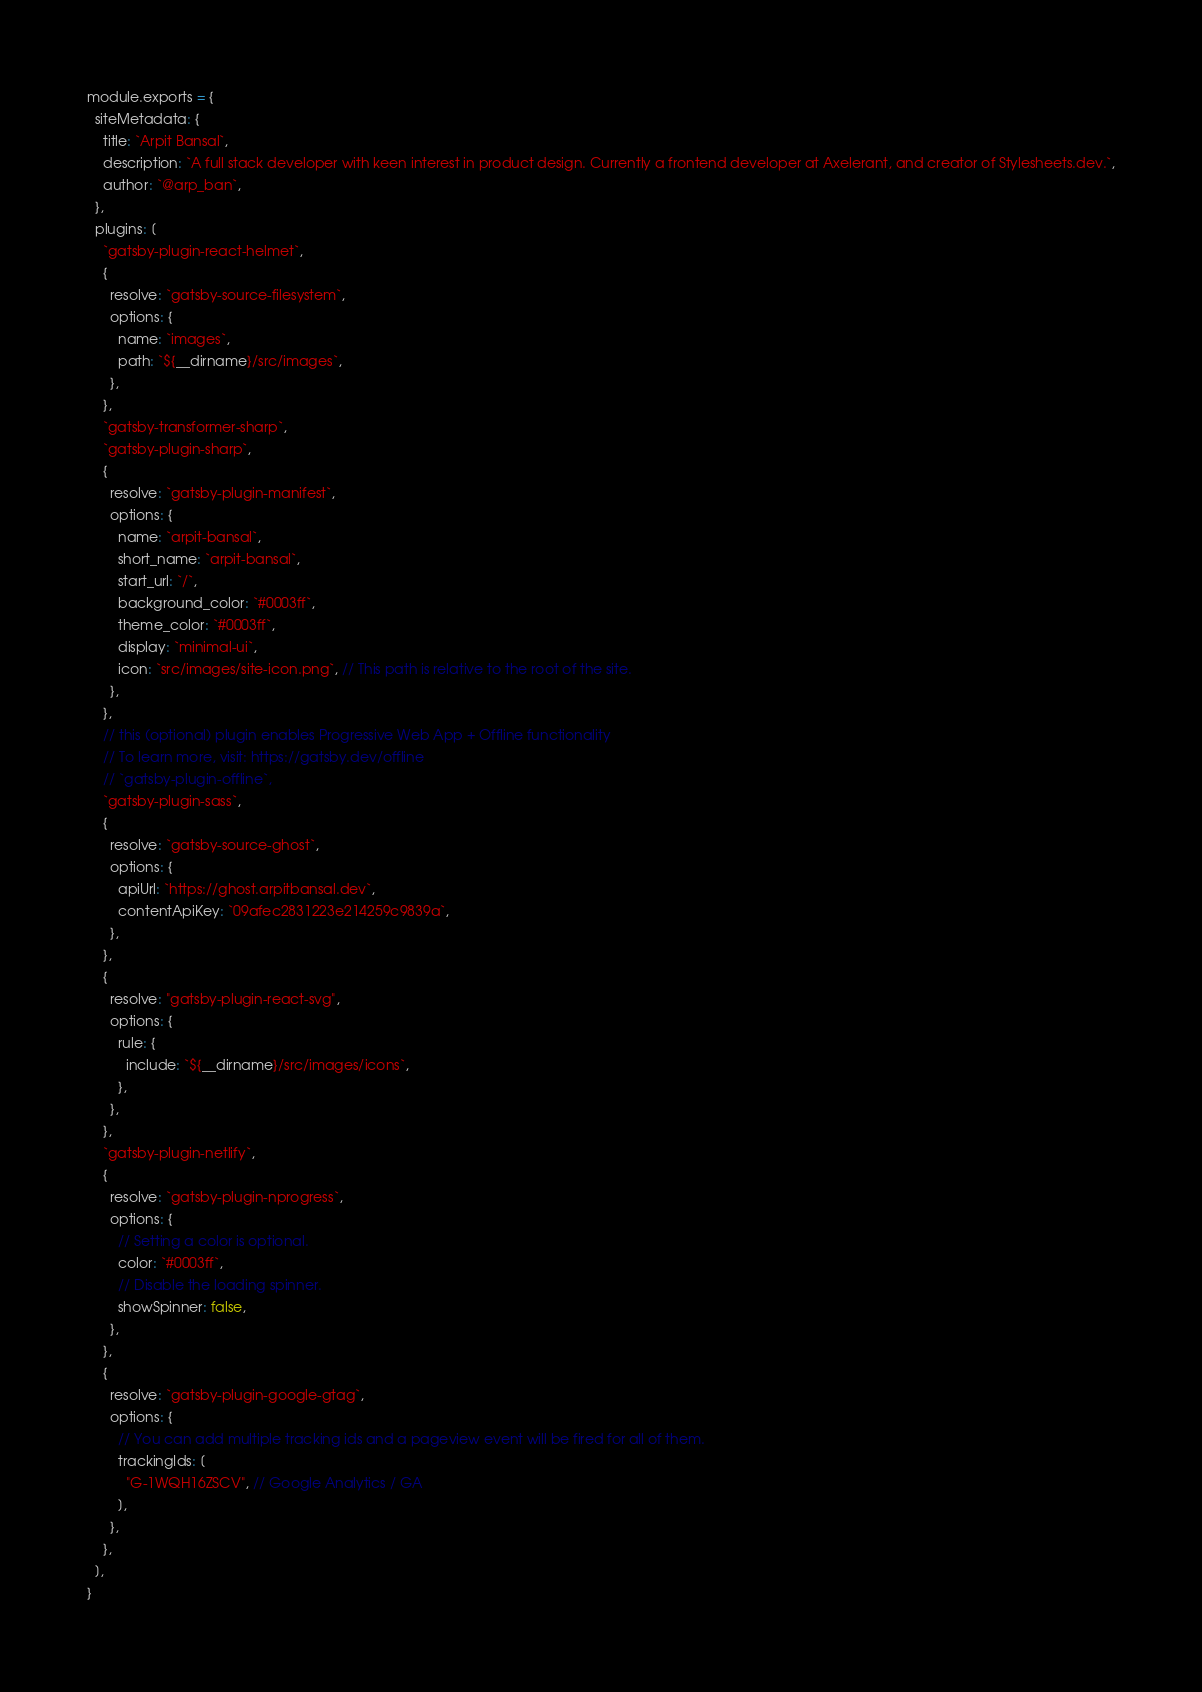<code> <loc_0><loc_0><loc_500><loc_500><_JavaScript_>module.exports = {
  siteMetadata: {
    title: `Arpit Bansal`,
    description: `A full stack developer with keen interest in product design. Currently a frontend developer at Axelerant, and creator of Stylesheets.dev.`,
    author: `@arp_ban`,
  },
  plugins: [
    `gatsby-plugin-react-helmet`,
    {
      resolve: `gatsby-source-filesystem`,
      options: {
        name: `images`,
        path: `${__dirname}/src/images`,
      },
    },
    `gatsby-transformer-sharp`,
    `gatsby-plugin-sharp`,
    {
      resolve: `gatsby-plugin-manifest`,
      options: {
        name: `arpit-bansal`,
        short_name: `arpit-bansal`,
        start_url: `/`,
        background_color: `#0003ff`,
        theme_color: `#0003ff`,
        display: `minimal-ui`,
        icon: `src/images/site-icon.png`, // This path is relative to the root of the site.
      },
    },
    // this (optional) plugin enables Progressive Web App + Offline functionality
    // To learn more, visit: https://gatsby.dev/offline
    // `gatsby-plugin-offline`,
    `gatsby-plugin-sass`,
    {
      resolve: `gatsby-source-ghost`,
      options: {
        apiUrl: `https://ghost.arpitbansal.dev`,
        contentApiKey: `09afec2831223e214259c9839a`,
      },
    },
    {
      resolve: "gatsby-plugin-react-svg",
      options: {
        rule: {
          include: `${__dirname}/src/images/icons`,
        },
      },
    },
    `gatsby-plugin-netlify`,
    {
      resolve: `gatsby-plugin-nprogress`,
      options: {
        // Setting a color is optional.
        color: `#0003ff`,
        // Disable the loading spinner.
        showSpinner: false,
      },
    },
    {
      resolve: `gatsby-plugin-google-gtag`,
      options: {
        // You can add multiple tracking ids and a pageview event will be fired for all of them.
        trackingIds: [
          "G-1WQH16ZSCV", // Google Analytics / GA
        ],
      },
    },
  ],
}
</code> 